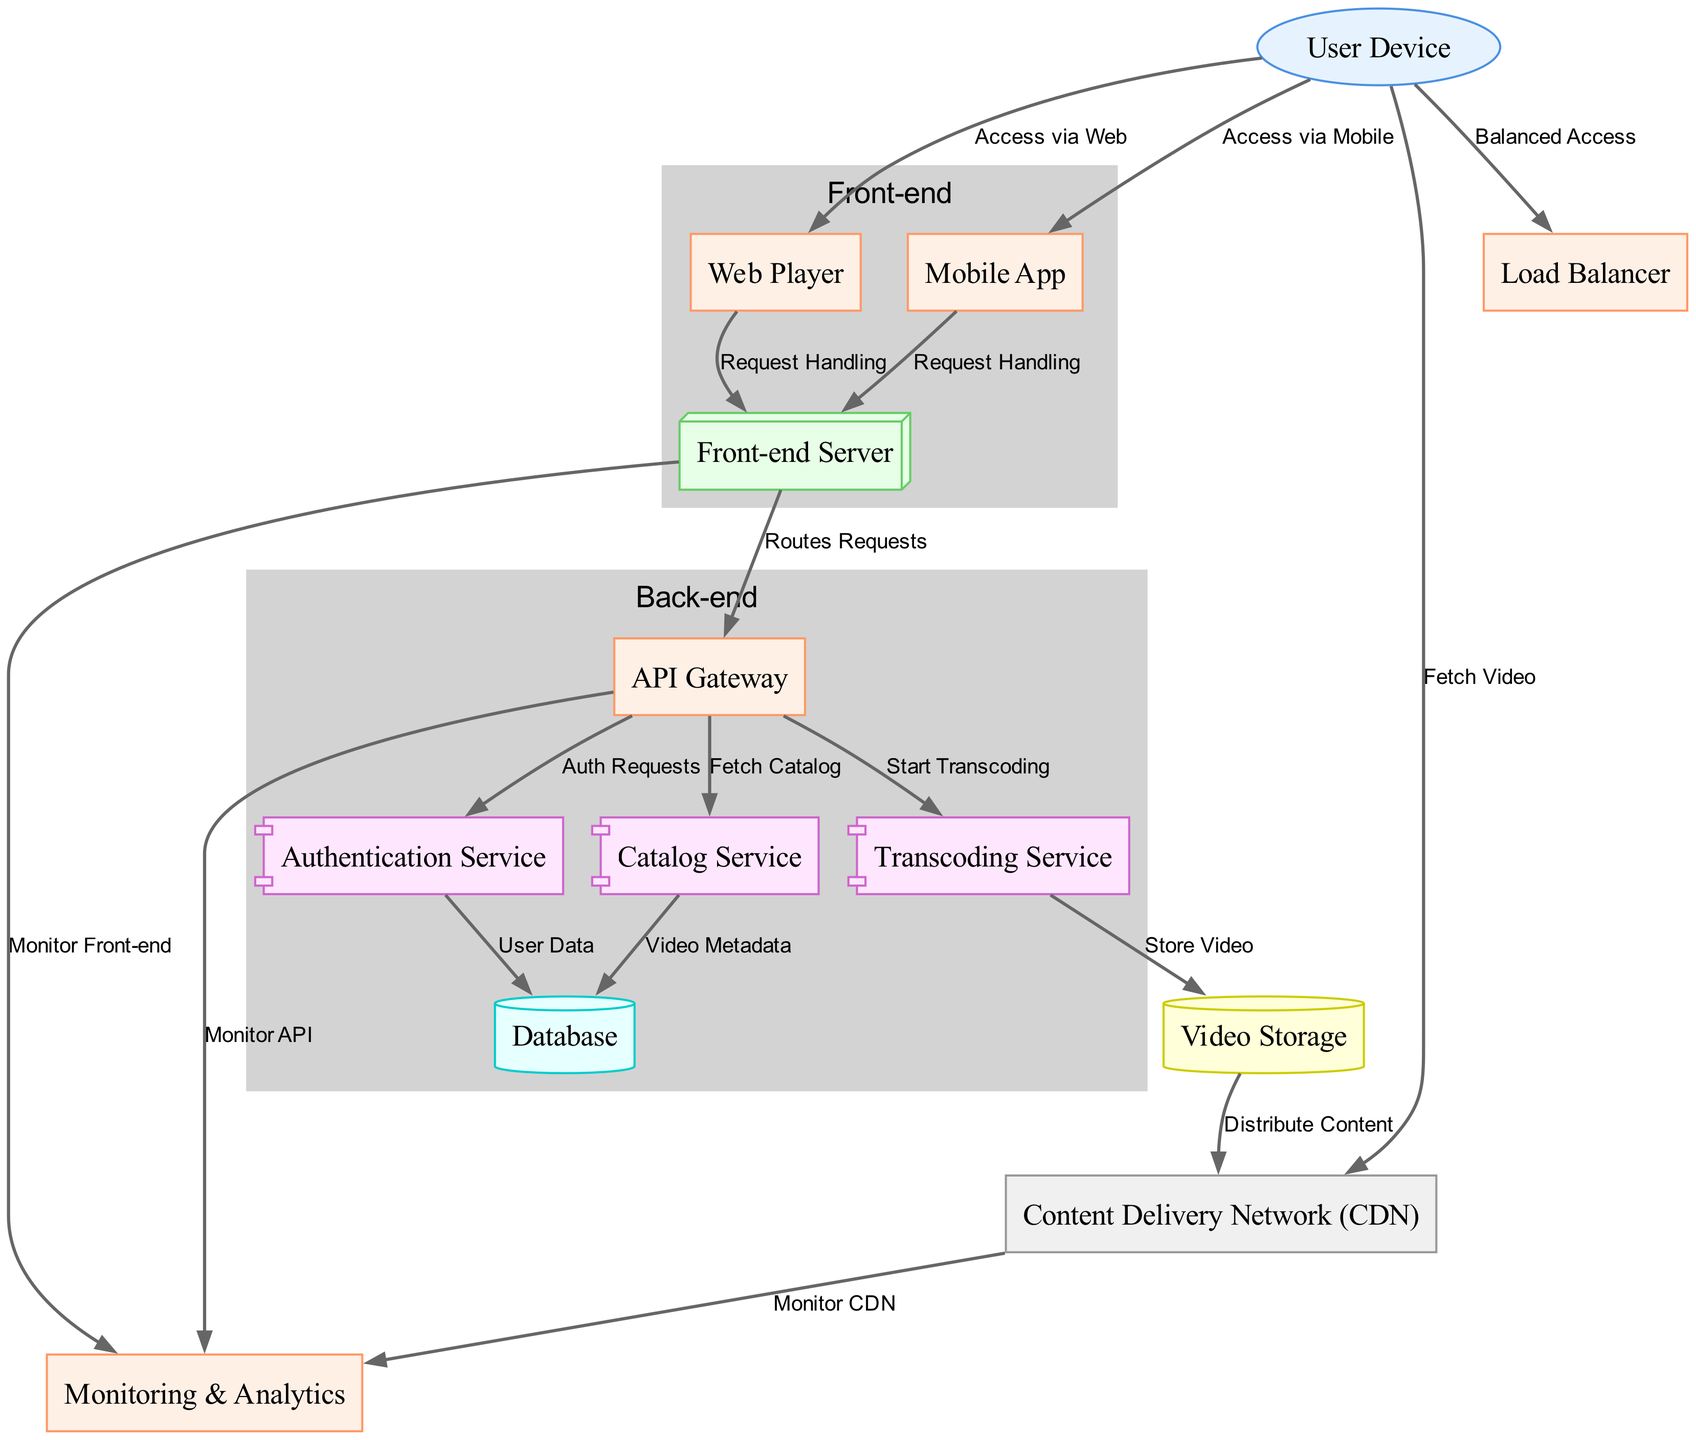What is the total number of nodes in the diagram? The diagram lists nodes with unique IDs (from 1 to 13) representing various components of the video streaming architecture. Counting these gives a total of 13 nodes.
Answer: 13 How many edges are represented in the diagram? The edges connect the various nodes, and by counting the connections listed, we find a total of 18 edges connecting different components within the architecture.
Answer: 18 What type of server is represented by node 4? Node 4 is labeled "Front-end Server," which indicates that it is a type of server specifically involved in handling requests from user devices.
Answer: Front-end Server Which node handles user authentication requests? The authentication requests are sent to the "Authentication Service," which is represented by node 6 in the diagram.
Answer: Authentication Service From which node does the "Transcoding Service" receive a request? The "Transcoding Service," represented by node 8, receives a request from the "API Gateway," denoted by node 5 in the diagram.
Answer: API Gateway What is the relationship between the "Video Storage" and the "Content Delivery Network"? The relationship indicates that the "Video Storage," represented by node 10, distributes content to the "Content Delivery Network," which is node 9.
Answer: Distribute Content What component is responsible for monitoring the API? The component responsible for monitoring the API is labeled "Monitor API," and it is connected directly from the "API Gateway" node (5) to the "Monitoring & Analytics" component (12).
Answer: Monitor API Which service is involved in fetching video metadata? The "Catalog Service," represented by node 7, is involved in fetching video metadata, as indicated by the connection to the database.
Answer: Catalog Service How does a user device access video content? A user device accesses video content by fetching video directly from the "Content Delivery Network," which is represented by node 9.
Answer: Fetch Video 